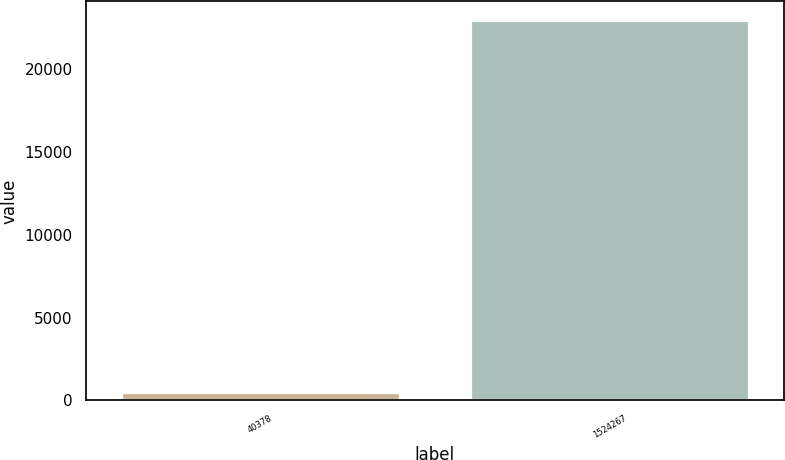<chart> <loc_0><loc_0><loc_500><loc_500><bar_chart><fcel>40378<fcel>1524267<nl><fcel>537<fcel>22914<nl></chart> 